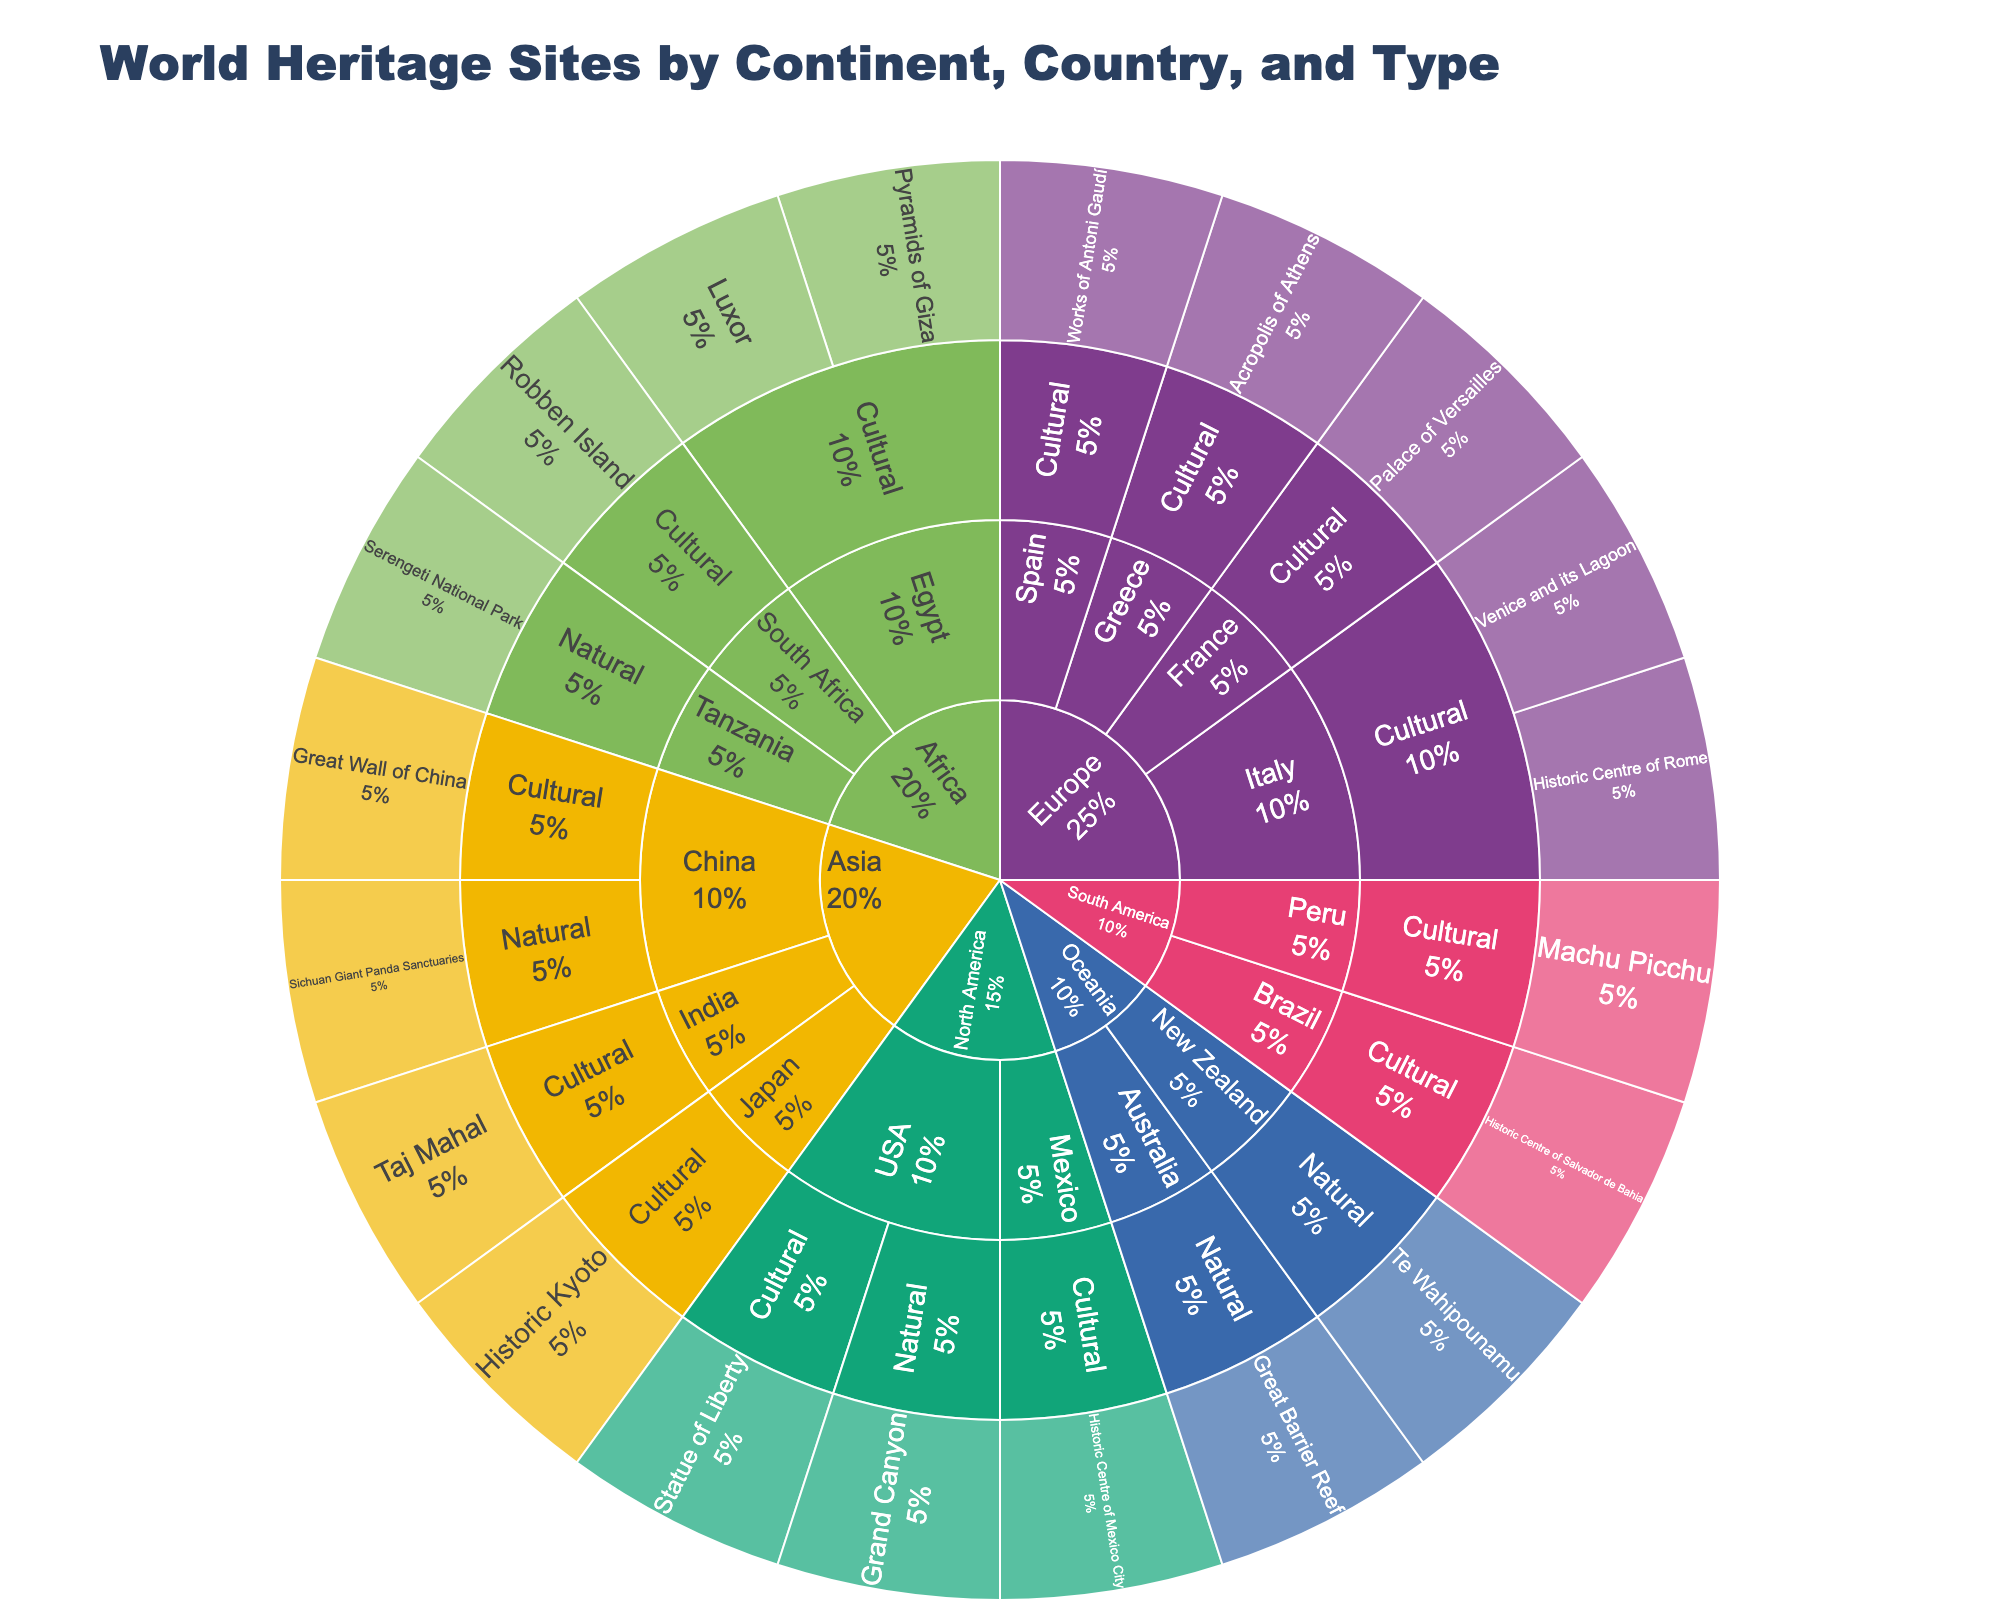How many continents are represented in the Sunburst Plot? The innermost circle of the Sunburst Plot represents continents. By counting the segments in this circle, you determine there are 6 segments.
Answer: 6 Which continent has the most cultural heritage sites? By examining the proportion of cultural heritage site segments in each continent, it is evident that Europe has the highest number of segments dedicated to cultural sites.
Answer: Europe Are there more natural heritage sites or cultural heritage sites in Africa? By looking at the sections for Africa in the Sunburst Plot, you can count the number of segments for each type. Africa has two cultural sites (Pyramids of Giza and Luxor in Egypt, Robben Island in South Africa) and one natural site (Serengeti National Park in Tanzania).
Answer: Cultural Which country in Asia has a natural heritage site? Under the Asia section, you can identify countries and the types of their heritage sites. China has a segment labeled "Sichuan Giant Panda Sanctuaries" under the natural category.
Answer: China How many World Heritage Sites does Italy have? By examining the segments for Italy under the Europe section in the Sunburst Plot, you can count three segments: Historic Centre of Rome, Venice and its Lagoon, and Palace of Versailles.
Answer: 2 What is the percentage of heritage sites in North America that are natural? Look at the North America section and count the natural sites segments. There is one natural site (Grand Canyon) and two total sites (Grand Canyon and Statue of Liberty), making the percentage 1/2 = 50%.
Answer: 50% Which continent has the least diversity in heritage site types? Observe each continent's segments. Oceania has only two segments, both of which are natural, indicating the least diversity in heritage site types.
Answer: Oceania How many countries in South America have World Heritage Sites? Under the South America section, you can count the segments representing countries. There are two segments: Peru and Brazil.
Answer: 2 Which heritage site in Europe is the largest contributor to its cultural segment? By examining the relative sizes of segments under the cultural category in Europe, "Historic Centre of Rome" in Italy appears to be one of the larger segments contributing to the cultural heritage sites.
Answer: Historic Centre of Rome Is there a continent that has an equal number of natural and cultural heritage sites? By comparing the number of segments for natural and cultural sites within each continent, it is evident that Oceania has an equal number of natural and cultural heritage sites, both being zero cultural and two natural. However, since the question might be interpreted incorrectly, we clarify essentially that only Oceania would have been equally distributed if there were cultural sites present.
Answer: Oceania 